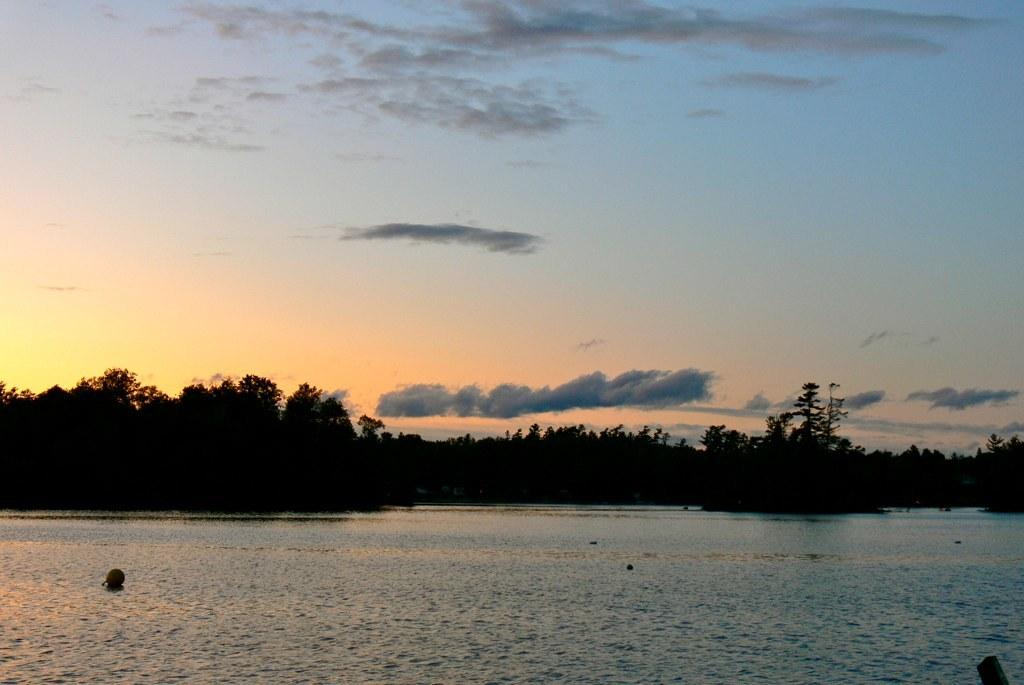What is visible in the image? Water, trees, and clouds are visible in the image. Can you describe the water in the image? The water is visible, but its specific characteristics are not mentioned in the facts. What type of vegetation is present in the image? Trees are present in the image. What is visible in the sky in the image? Clouds are visible in the sky in the image. What rate of expansion can be observed in the notebook in the image? There is no notebook present in the image, so it is not possible to determine the rate of expansion. 